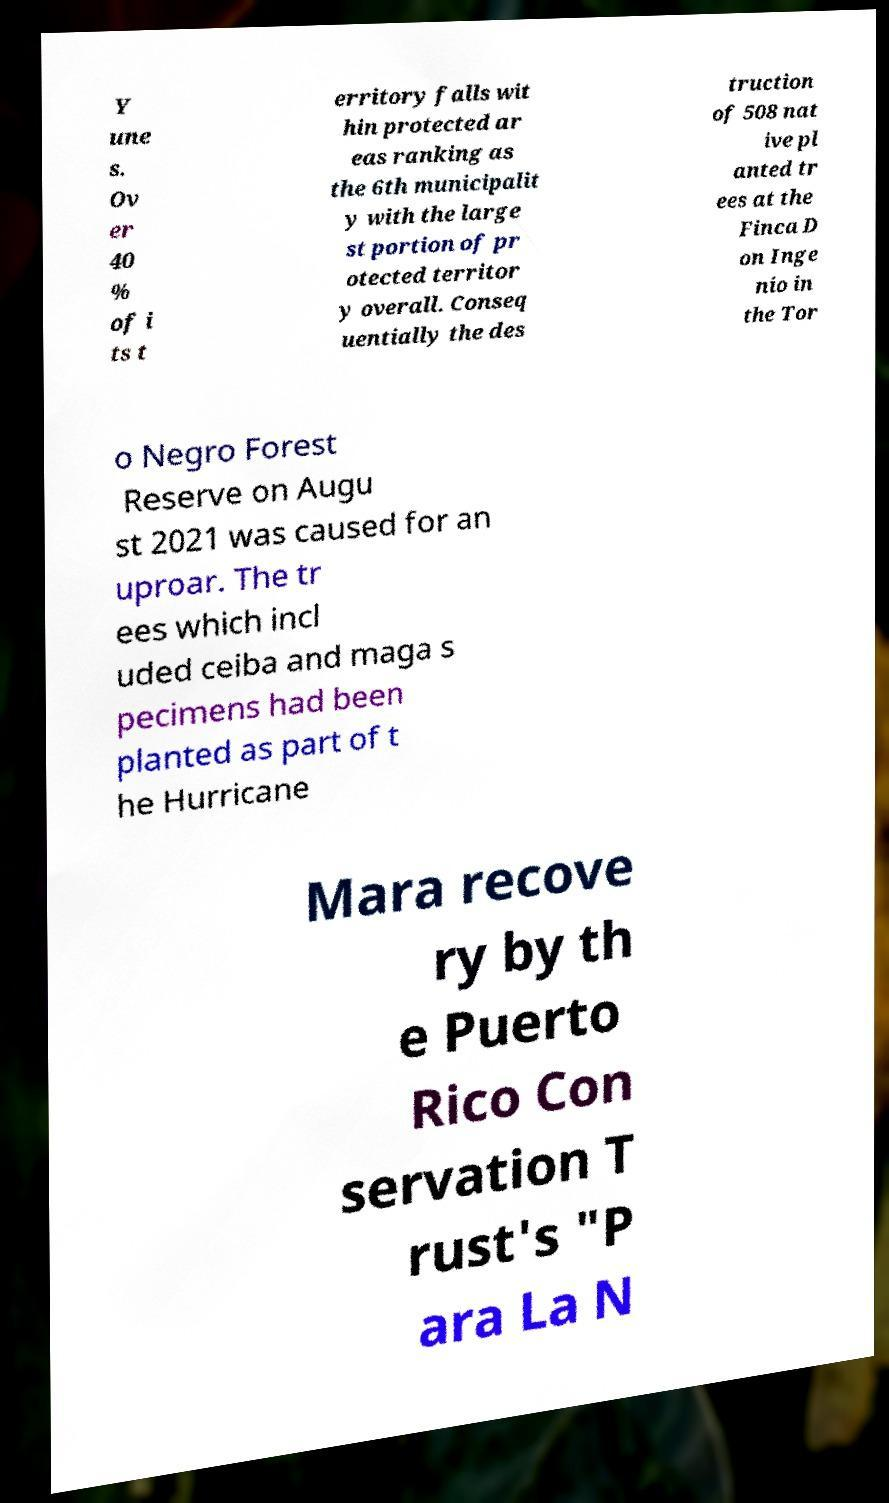Could you extract and type out the text from this image? Y une s. Ov er 40 % of i ts t erritory falls wit hin protected ar eas ranking as the 6th municipalit y with the large st portion of pr otected territor y overall. Conseq uentially the des truction of 508 nat ive pl anted tr ees at the Finca D on Inge nio in the Tor o Negro Forest Reserve on Augu st 2021 was caused for an uproar. The tr ees which incl uded ceiba and maga s pecimens had been planted as part of t he Hurricane Mara recove ry by th e Puerto Rico Con servation T rust's "P ara La N 